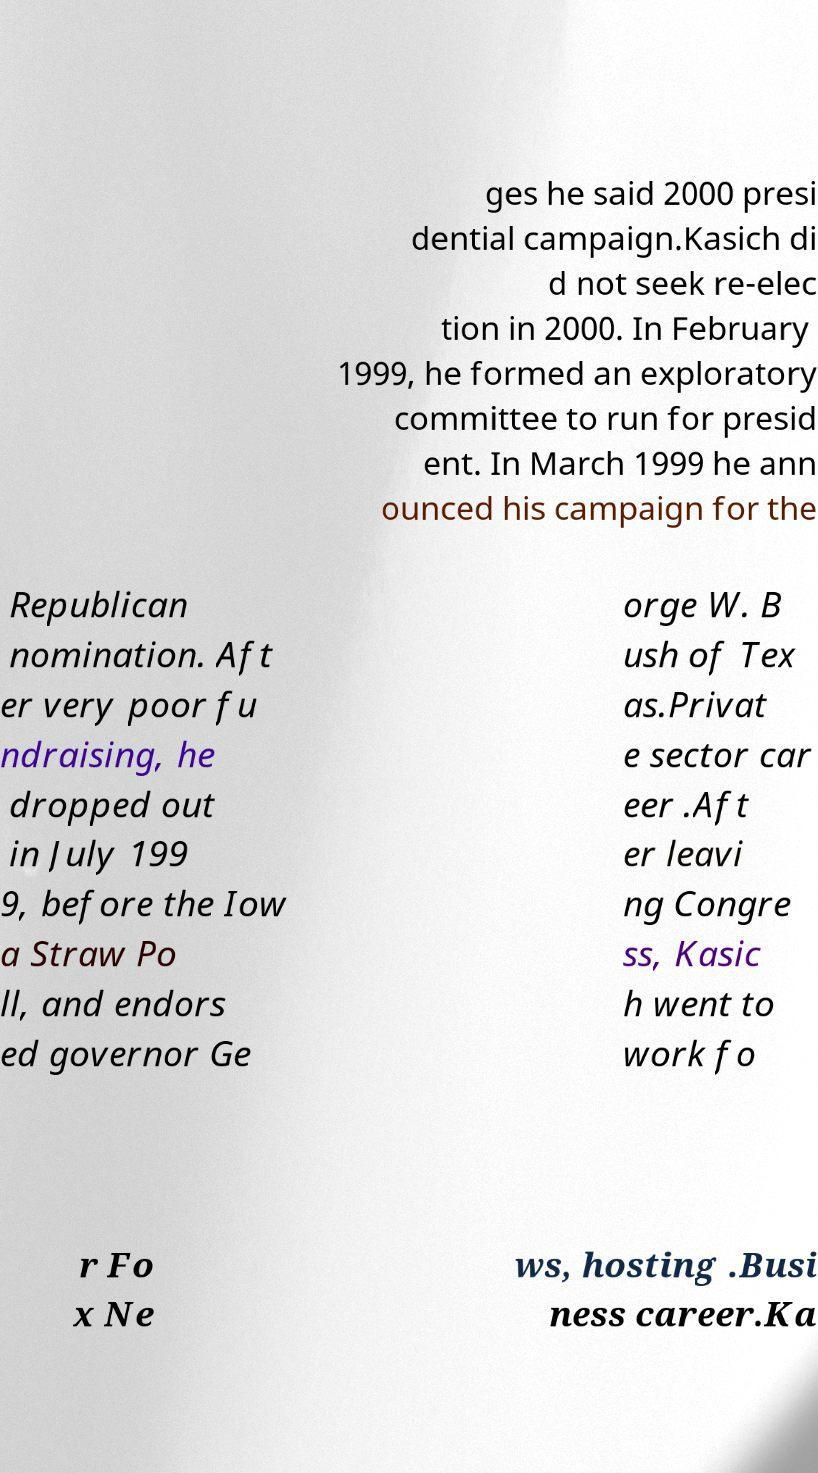Can you read and provide the text displayed in the image?This photo seems to have some interesting text. Can you extract and type it out for me? ges he said 2000 presi dential campaign.Kasich di d not seek re-elec tion in 2000. In February 1999, he formed an exploratory committee to run for presid ent. In March 1999 he ann ounced his campaign for the Republican nomination. Aft er very poor fu ndraising, he dropped out in July 199 9, before the Iow a Straw Po ll, and endors ed governor Ge orge W. B ush of Tex as.Privat e sector car eer .Aft er leavi ng Congre ss, Kasic h went to work fo r Fo x Ne ws, hosting .Busi ness career.Ka 